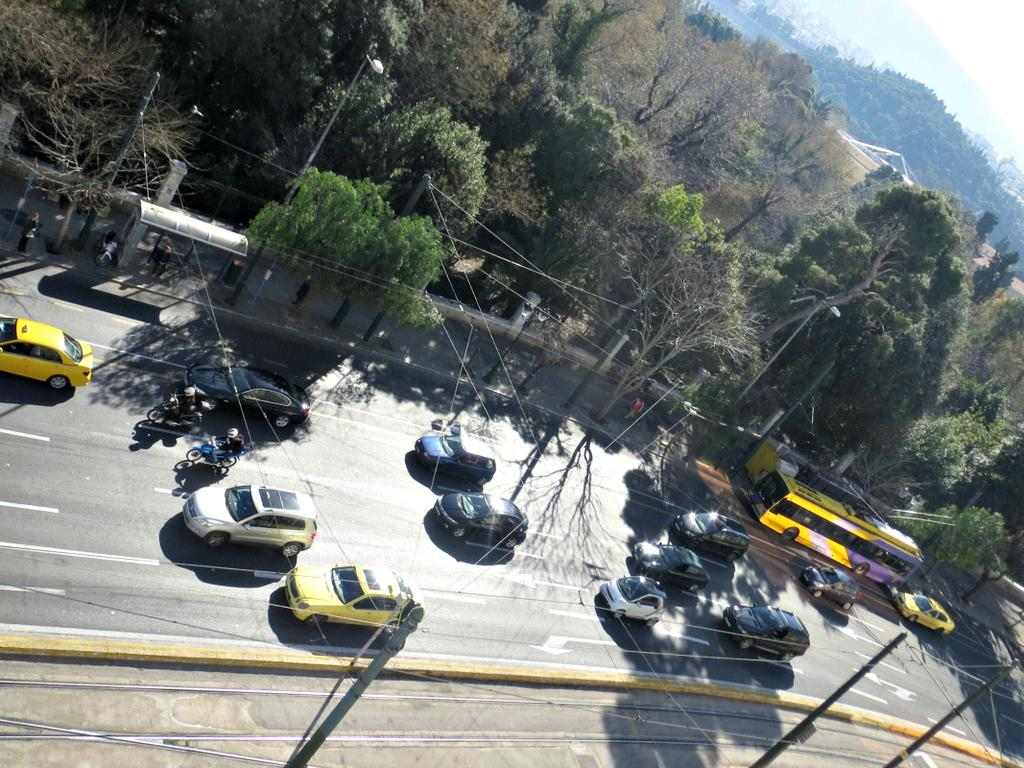What type of vehicles can be seen on the road in the image? There are cars on the road in the image. What natural elements are present in the image? There are trees and mountains in the image. What type of vegetation can be seen in the image? There are plants in the image. What man-made structures can be seen in the image? There are poles in the image. What type of record is being played on the poles in the image? There are no records or music players present in the image; the poles are likely utility poles. How is the distribution of cars and trees being managed in the image? The image does not show any management or distribution of cars and trees; it simply depicts them as they are. 